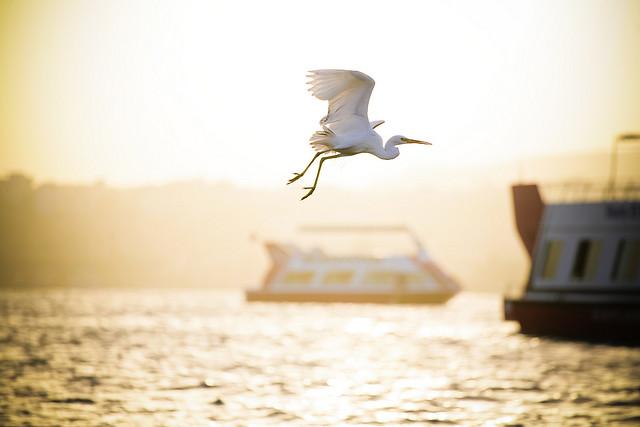What is the color of the back of the bird?
Write a very short answer. White. What are those birds made out of?
Concise answer only. Feathers. What type of bird is in the photo?
Short answer required. Pelican. How many birds are in the picture?
Keep it brief. 1. What kind of bird is this?
Be succinct. Seagull. What type of bird is this?
Give a very brief answer. Crane. Are their boats in the picture?
Answer briefly. Yes. Can this bird fly?
Keep it brief. Yes. 